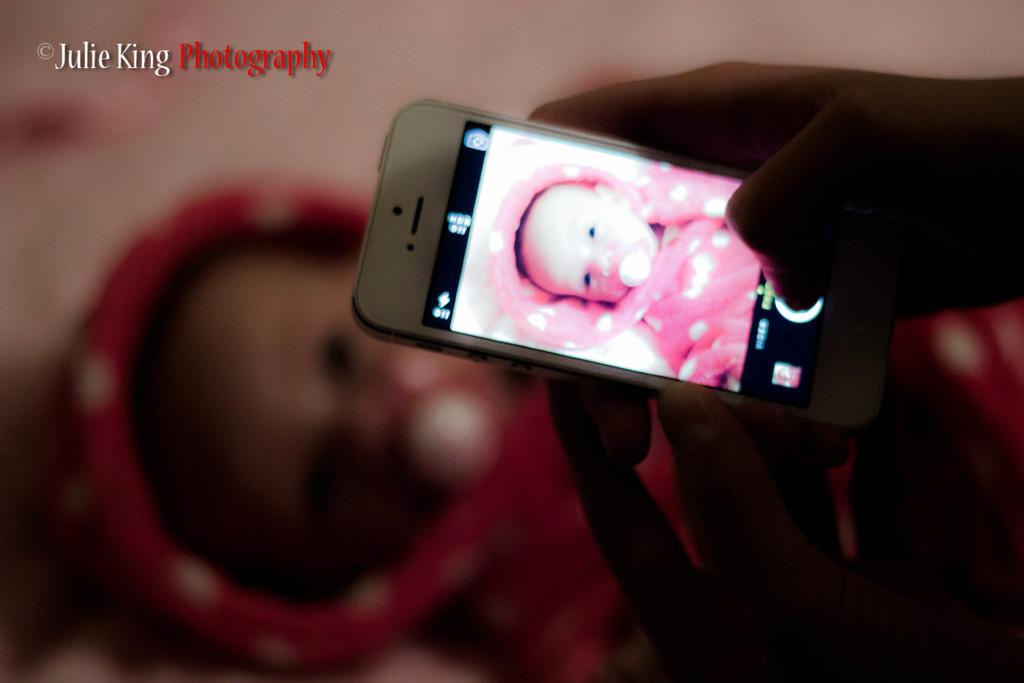Who or what is in the foreground of the picture? There is a person in the foreground of the picture. What is the person holding in the image? The person is holding a mobile. What can be seen on the mobile? There is a picture of a kid on the mobile. Can you describe the background of the image? The background of the image is blurred. What type of cork can be seen floating in the harbor in the image? There is no harbor or cork present in the image. How many mittens are visible on the person's hands in the image? The person in the image is not wearing any mittens. 